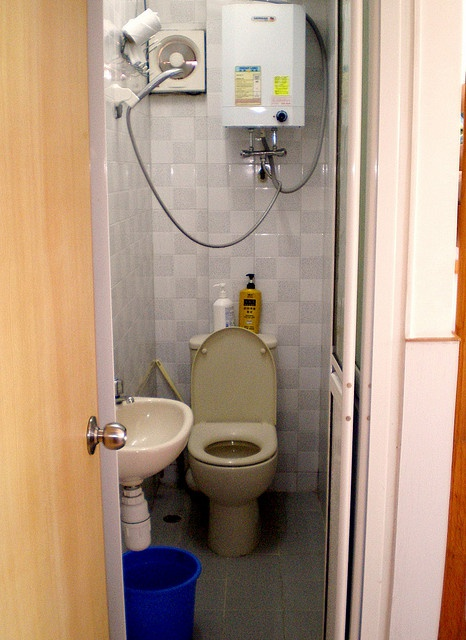Describe the objects in this image and their specific colors. I can see toilet in tan, gray, and black tones, sink in tan tones, bottle in tan, olive, black, and maroon tones, and bottle in tan, darkgray, and lightgray tones in this image. 